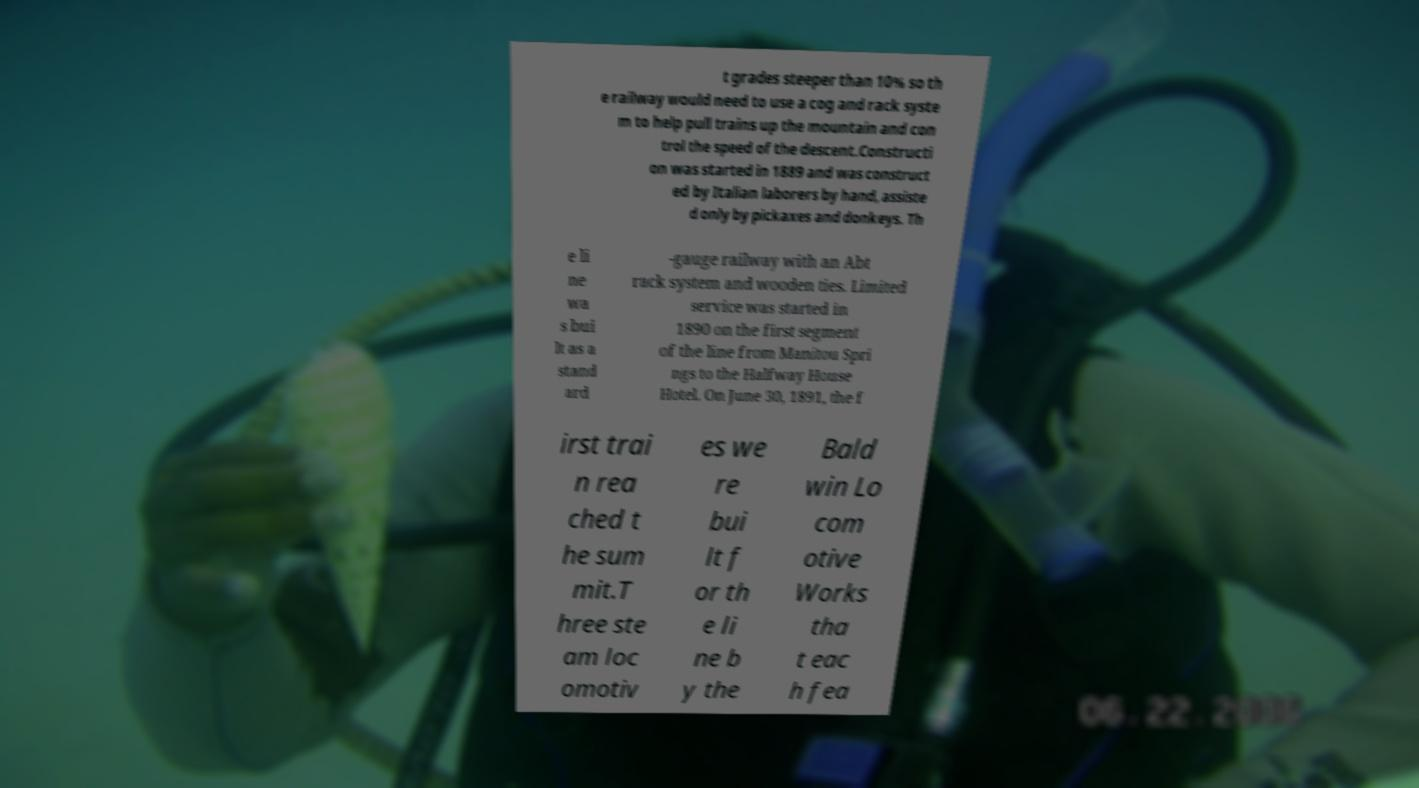There's text embedded in this image that I need extracted. Can you transcribe it verbatim? t grades steeper than 10% so th e railway would need to use a cog and rack syste m to help pull trains up the mountain and con trol the speed of the descent.Constructi on was started in 1889 and was construct ed by Italian laborers by hand, assiste d only by pickaxes and donkeys. Th e li ne wa s bui lt as a stand ard -gauge railway with an Abt rack system and wooden ties. Limited service was started in 1890 on the first segment of the line from Manitou Spri ngs to the Halfway House Hotel. On June 30, 1891, the f irst trai n rea ched t he sum mit.T hree ste am loc omotiv es we re bui lt f or th e li ne b y the Bald win Lo com otive Works tha t eac h fea 